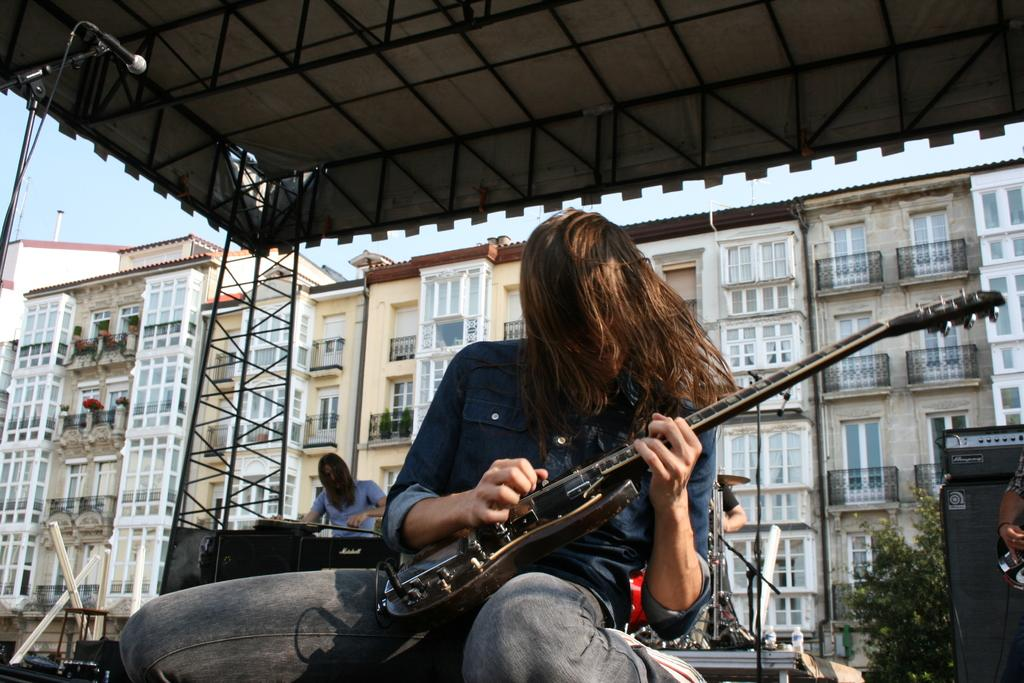What is the person in the image doing? The person is sitting and holding a guitar. What can be seen in the background of the image? There is a building and the sky visible in the background of the image. Are there any other people in the image? Yes, there is another person standing in the background of the image. What type of destruction is being caused by the authority in the image? There is no destruction or authority present in the image; it features a person sitting with a guitar and a background with a building and the sky. 